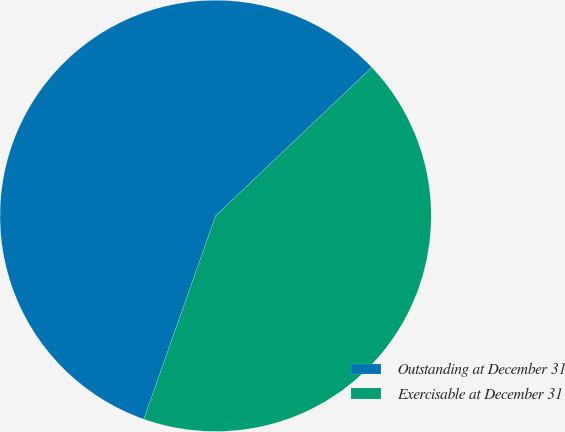Convert chart to OTSL. <chart><loc_0><loc_0><loc_500><loc_500><pie_chart><fcel>Outstanding at December 31<fcel>Exercisable at December 31<nl><fcel>57.5%<fcel>42.5%<nl></chart> 